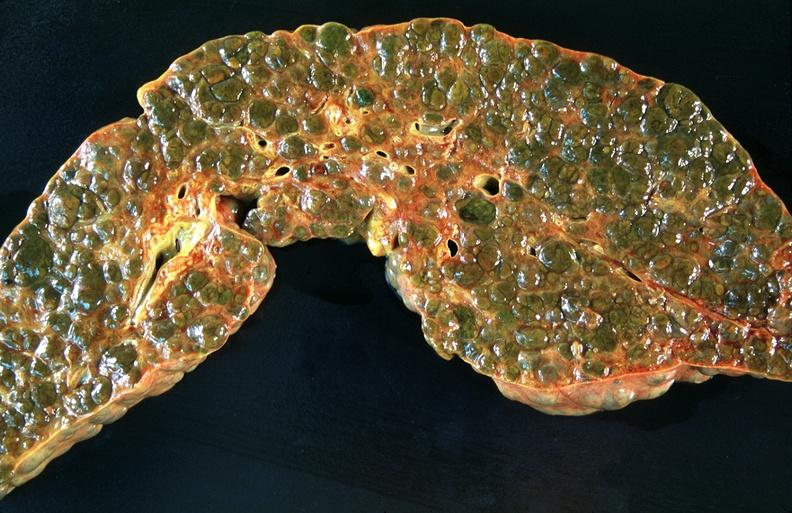does this image show liver, macronodular cirrhosis, hcv?
Answer the question using a single word or phrase. Yes 